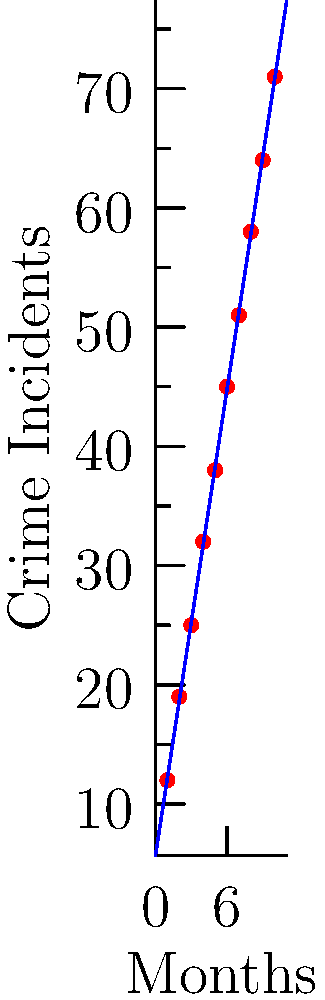As a criminology professor analyzing crime trends, you've plotted the number of reported incidents in a specific neighborhood over 10 months. Using the scatter plot and best-fit line, what is the projected number of crime incidents for the 12th month if the trend continues? Round your answer to the nearest whole number. To solve this problem, we'll follow these steps:

1. Identify the equation of the best-fit line:
   The line is in the form $y = mx + b$, where $m$ is the slope and $b$ is the y-intercept.

2. Calculate the slope ($m$):
   $m = \frac{y_2 - y_1}{x_2 - x_1} \approx \frac{71 - 12}{10 - 1} = \frac{59}{9} \approx 6.56$

3. Calculate the y-intercept ($b$):
   Using a point on the line, say (1, 12):
   $12 = 6.56(1) + b$
   $b = 12 - 6.56 = 5.44$

4. Write the equation of the best-fit line:
   $y = 6.56x + 5.44$

5. Predict the number of incidents for the 12th month:
   $y = 6.56(12) + 5.44 = 78.72 + 5.44 = 84.16$

6. Round to the nearest whole number:
   84.16 rounds to 84

Therefore, the projected number of crime incidents for the 12th month is 84.
Answer: 84 incidents 